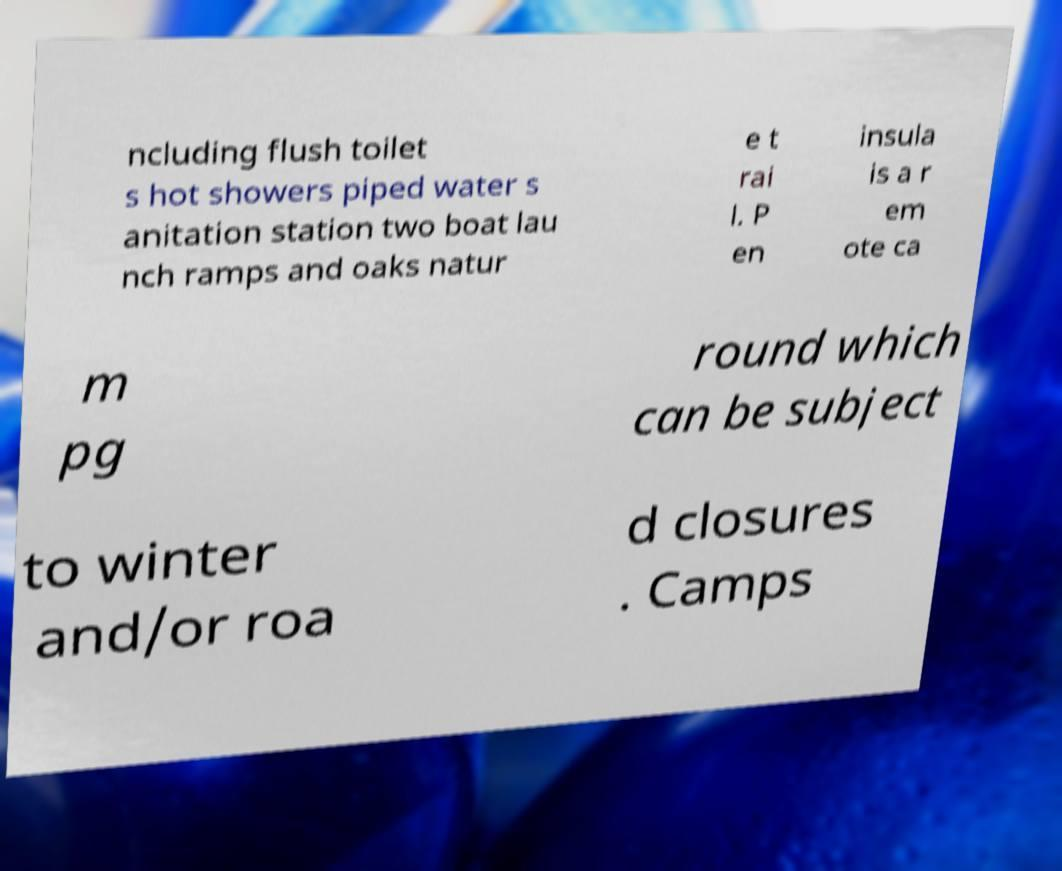Could you extract and type out the text from this image? ncluding flush toilet s hot showers piped water s anitation station two boat lau nch ramps and oaks natur e t rai l. P en insula is a r em ote ca m pg round which can be subject to winter and/or roa d closures . Camps 